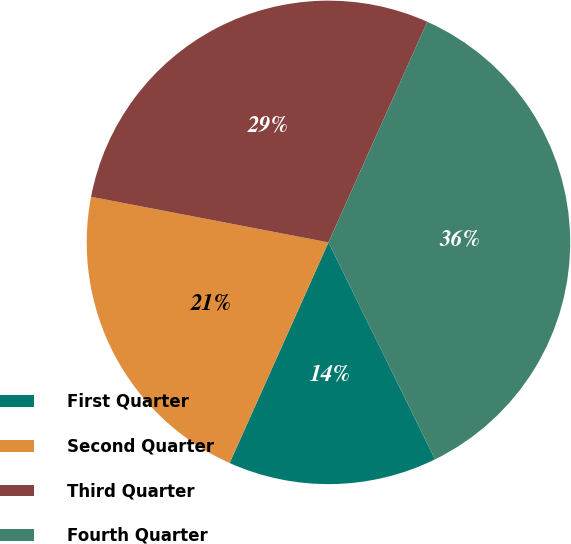Convert chart. <chart><loc_0><loc_0><loc_500><loc_500><pie_chart><fcel>First Quarter<fcel>Second Quarter<fcel>Third Quarter<fcel>Fourth Quarter<nl><fcel>13.97%<fcel>21.32%<fcel>28.68%<fcel>36.03%<nl></chart> 